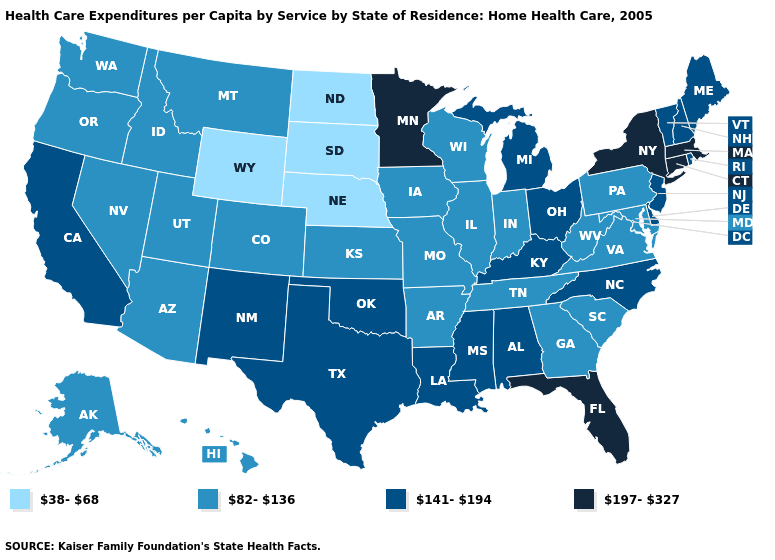Which states have the highest value in the USA?
Short answer required. Connecticut, Florida, Massachusetts, Minnesota, New York. What is the lowest value in states that border West Virginia?
Answer briefly. 82-136. What is the value of Maryland?
Keep it brief. 82-136. What is the value of Kansas?
Quick response, please. 82-136. What is the value of Michigan?
Be succinct. 141-194. What is the value of South Carolina?
Give a very brief answer. 82-136. Name the states that have a value in the range 38-68?
Answer briefly. Nebraska, North Dakota, South Dakota, Wyoming. Does Florida have the same value as Massachusetts?
Keep it brief. Yes. Name the states that have a value in the range 141-194?
Short answer required. Alabama, California, Delaware, Kentucky, Louisiana, Maine, Michigan, Mississippi, New Hampshire, New Jersey, New Mexico, North Carolina, Ohio, Oklahoma, Rhode Island, Texas, Vermont. Among the states that border California , which have the lowest value?
Answer briefly. Arizona, Nevada, Oregon. Name the states that have a value in the range 38-68?
Concise answer only. Nebraska, North Dakota, South Dakota, Wyoming. Name the states that have a value in the range 38-68?
Quick response, please. Nebraska, North Dakota, South Dakota, Wyoming. What is the value of Oregon?
Be succinct. 82-136. What is the value of California?
Write a very short answer. 141-194. 